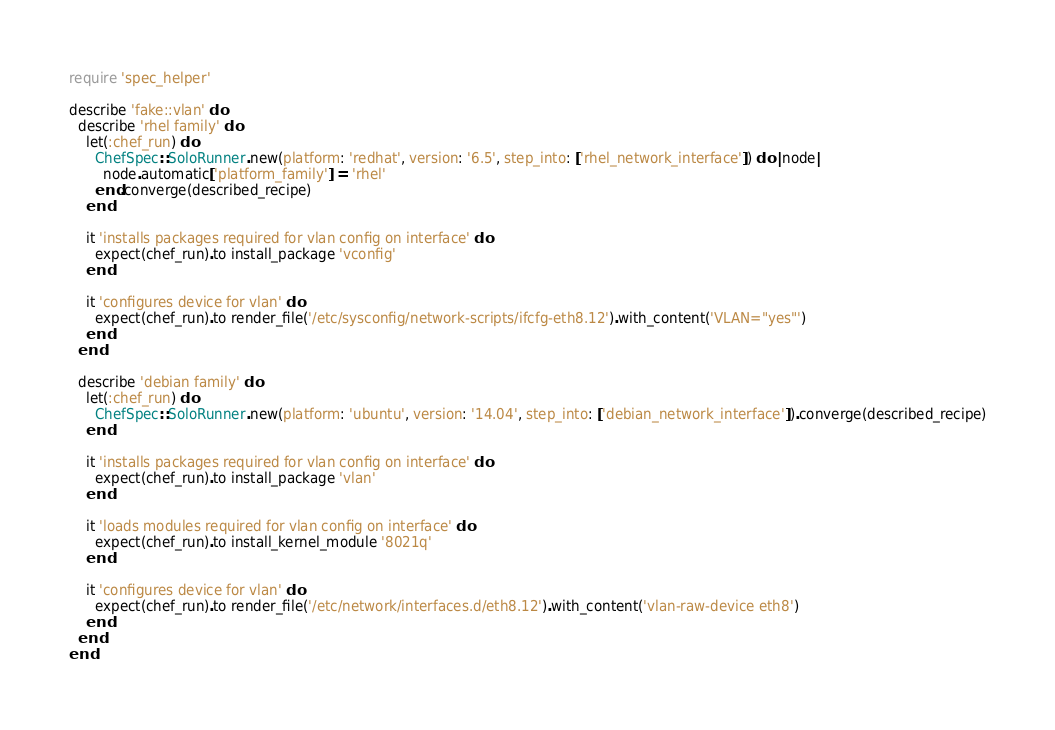Convert code to text. <code><loc_0><loc_0><loc_500><loc_500><_Ruby_>require 'spec_helper'

describe 'fake::vlan' do
  describe 'rhel family' do
    let(:chef_run) do
      ChefSpec::SoloRunner.new(platform: 'redhat', version: '6.5', step_into: ['rhel_network_interface']) do |node|
        node.automatic['platform_family'] = 'rhel'
      end.converge(described_recipe)
    end

    it 'installs packages required for vlan config on interface' do
      expect(chef_run).to install_package 'vconfig'
    end

    it 'configures device for vlan' do
      expect(chef_run).to render_file('/etc/sysconfig/network-scripts/ifcfg-eth8.12').with_content('VLAN="yes"')
    end
  end

  describe 'debian family' do
    let(:chef_run) do
      ChefSpec::SoloRunner.new(platform: 'ubuntu', version: '14.04', step_into: ['debian_network_interface']).converge(described_recipe)
    end

    it 'installs packages required for vlan config on interface' do
      expect(chef_run).to install_package 'vlan'
    end

    it 'loads modules required for vlan config on interface' do
      expect(chef_run).to install_kernel_module '8021q'
    end

    it 'configures device for vlan' do
      expect(chef_run).to render_file('/etc/network/interfaces.d/eth8.12').with_content('vlan-raw-device eth8')
    end
  end
end
</code> 